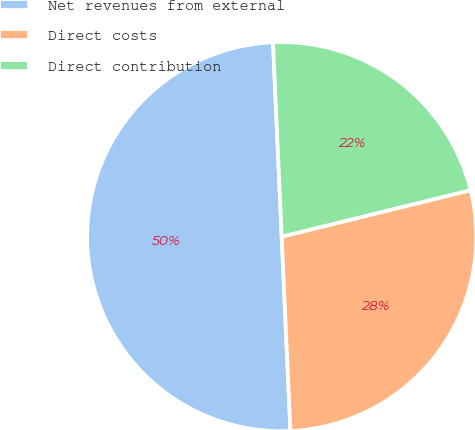<chart> <loc_0><loc_0><loc_500><loc_500><pie_chart><fcel>Net revenues from external<fcel>Direct costs<fcel>Direct contribution<nl><fcel>50.0%<fcel>28.13%<fcel>21.87%<nl></chart> 